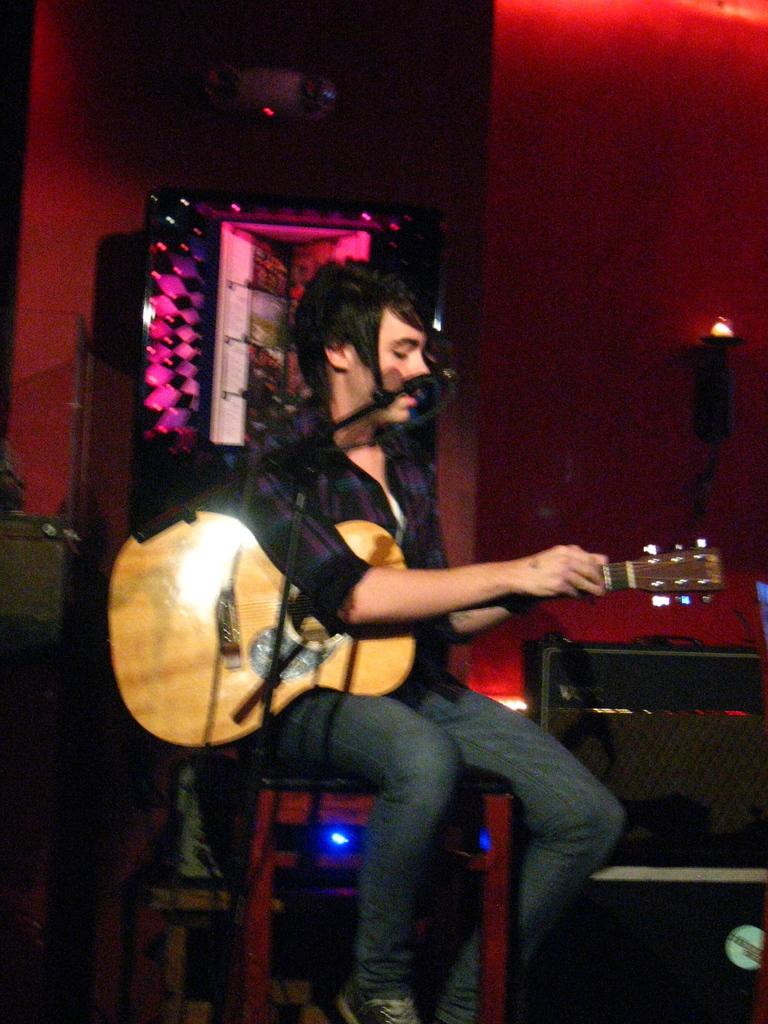Who is present in the image? There is a man in the image. What is the man doing in the image? The man is sitting on a chair and holding a guitar. What object is in front of the man? There is a microphone in front of the man. What type of shade is covering the mailbox in the image? There is no mailbox or shade present in the image. What kind of flowers are in the vase on the table in the image? There is no vase or flowers present in the image. 